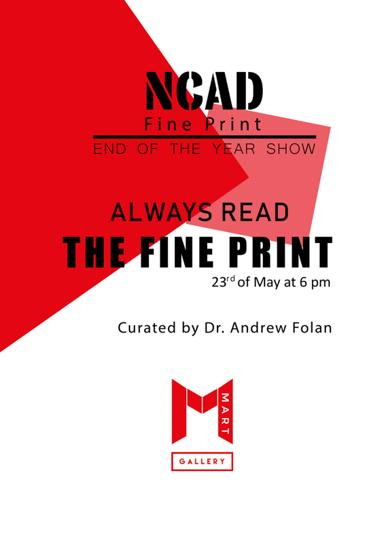Who is the curator of the event? Dr. Andrew Folan is the curator of this intriguing show, known for his insightful selections and expertise in fine print art. 